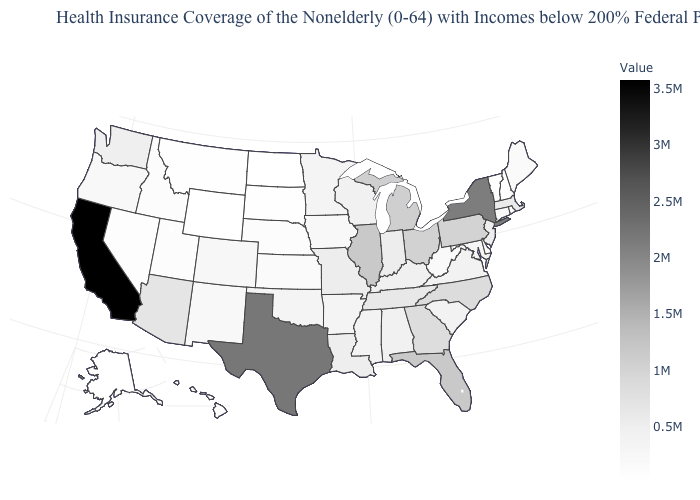Which states have the lowest value in the West?
Keep it brief. Wyoming. Does California have the highest value in the USA?
Write a very short answer. Yes. Does Hawaii have the lowest value in the West?
Short answer required. No. Among the states that border Wyoming , which have the highest value?
Concise answer only. Colorado. Among the states that border Ohio , which have the lowest value?
Answer briefly. West Virginia. 